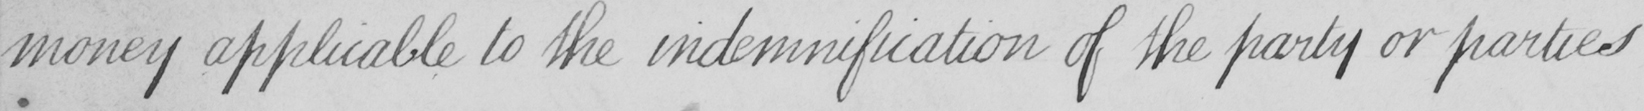Please provide the text content of this handwritten line. money applicable to the indemnification of the party or parties 